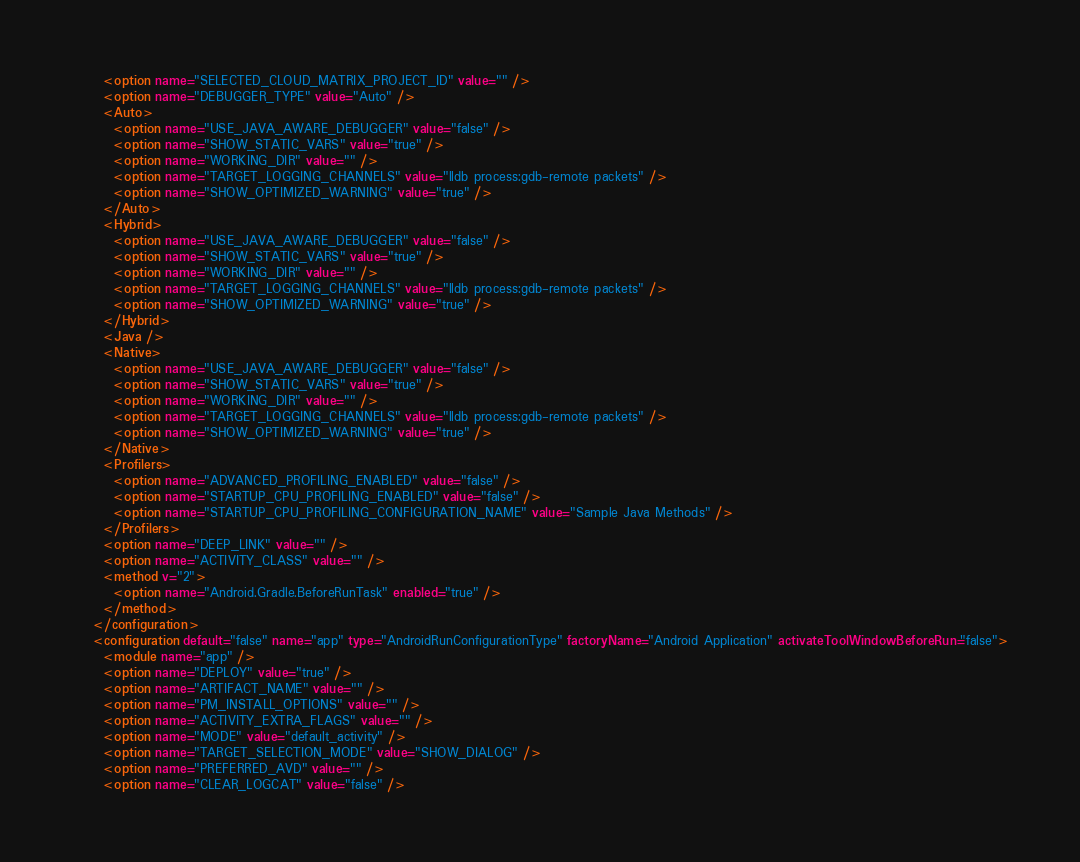Convert code to text. <code><loc_0><loc_0><loc_500><loc_500><_XML_>      <option name="SELECTED_CLOUD_MATRIX_PROJECT_ID" value="" />
      <option name="DEBUGGER_TYPE" value="Auto" />
      <Auto>
        <option name="USE_JAVA_AWARE_DEBUGGER" value="false" />
        <option name="SHOW_STATIC_VARS" value="true" />
        <option name="WORKING_DIR" value="" />
        <option name="TARGET_LOGGING_CHANNELS" value="lldb process:gdb-remote packets" />
        <option name="SHOW_OPTIMIZED_WARNING" value="true" />
      </Auto>
      <Hybrid>
        <option name="USE_JAVA_AWARE_DEBUGGER" value="false" />
        <option name="SHOW_STATIC_VARS" value="true" />
        <option name="WORKING_DIR" value="" />
        <option name="TARGET_LOGGING_CHANNELS" value="lldb process:gdb-remote packets" />
        <option name="SHOW_OPTIMIZED_WARNING" value="true" />
      </Hybrid>
      <Java />
      <Native>
        <option name="USE_JAVA_AWARE_DEBUGGER" value="false" />
        <option name="SHOW_STATIC_VARS" value="true" />
        <option name="WORKING_DIR" value="" />
        <option name="TARGET_LOGGING_CHANNELS" value="lldb process:gdb-remote packets" />
        <option name="SHOW_OPTIMIZED_WARNING" value="true" />
      </Native>
      <Profilers>
        <option name="ADVANCED_PROFILING_ENABLED" value="false" />
        <option name="STARTUP_CPU_PROFILING_ENABLED" value="false" />
        <option name="STARTUP_CPU_PROFILING_CONFIGURATION_NAME" value="Sample Java Methods" />
      </Profilers>
      <option name="DEEP_LINK" value="" />
      <option name="ACTIVITY_CLASS" value="" />
      <method v="2">
        <option name="Android.Gradle.BeforeRunTask" enabled="true" />
      </method>
    </configuration>
    <configuration default="false" name="app" type="AndroidRunConfigurationType" factoryName="Android Application" activateToolWindowBeforeRun="false">
      <module name="app" />
      <option name="DEPLOY" value="true" />
      <option name="ARTIFACT_NAME" value="" />
      <option name="PM_INSTALL_OPTIONS" value="" />
      <option name="ACTIVITY_EXTRA_FLAGS" value="" />
      <option name="MODE" value="default_activity" />
      <option name="TARGET_SELECTION_MODE" value="SHOW_DIALOG" />
      <option name="PREFERRED_AVD" value="" />
      <option name="CLEAR_LOGCAT" value="false" /></code> 